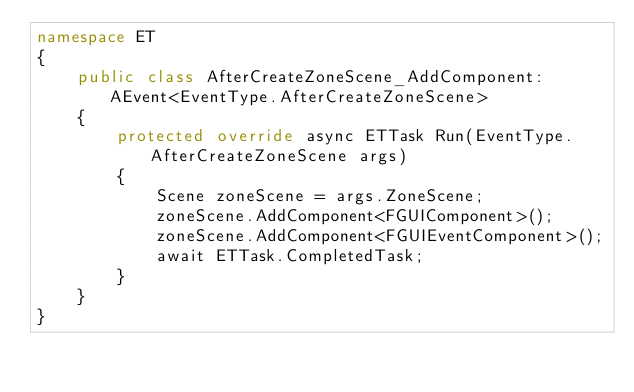<code> <loc_0><loc_0><loc_500><loc_500><_C#_>namespace ET
{
    public class AfterCreateZoneScene_AddComponent: AEvent<EventType.AfterCreateZoneScene>
    {
        protected override async ETTask Run(EventType.AfterCreateZoneScene args)
        {
            Scene zoneScene = args.ZoneScene;
            zoneScene.AddComponent<FGUIComponent>();
            zoneScene.AddComponent<FGUIEventComponent>();
            await ETTask.CompletedTask;
        }
    }
}</code> 